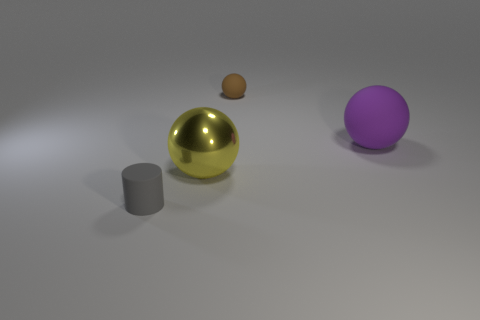Subtract all large rubber spheres. How many spheres are left? 2 Subtract all spheres. How many objects are left? 1 Add 3 large yellow metallic spheres. How many objects exist? 7 Subtract all yellow spheres. How many spheres are left? 2 Subtract 0 cyan cylinders. How many objects are left? 4 Subtract 1 cylinders. How many cylinders are left? 0 Subtract all yellow spheres. Subtract all gray cylinders. How many spheres are left? 2 Subtract all cyan cylinders. How many blue spheres are left? 0 Subtract all tiny brown metallic balls. Subtract all rubber objects. How many objects are left? 1 Add 4 balls. How many balls are left? 7 